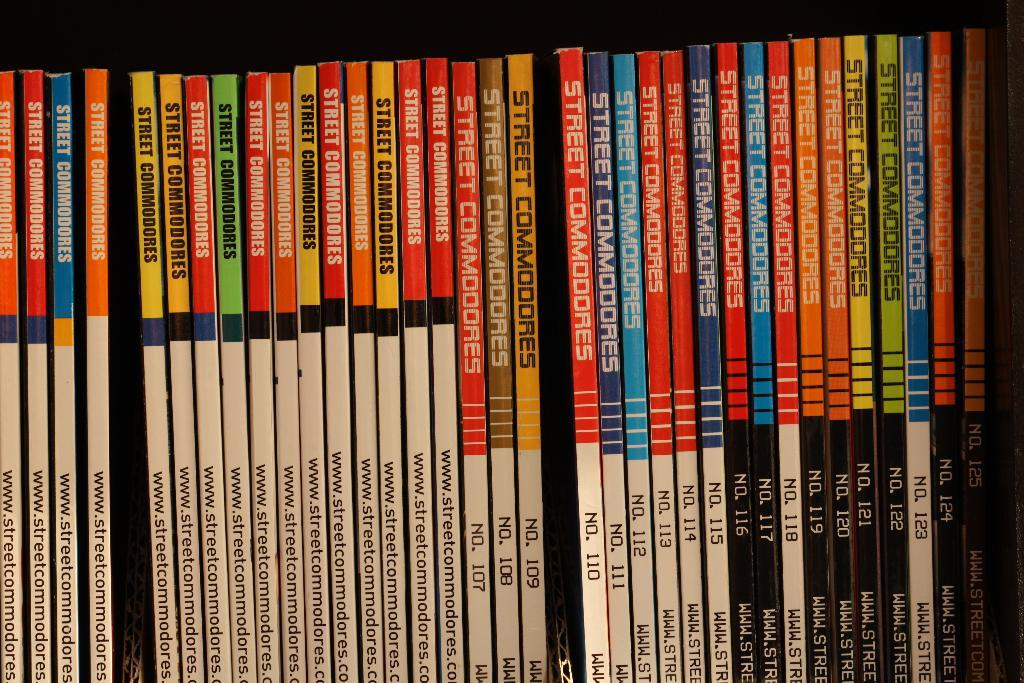<image>
Render a clear and concise summary of the photo. a lot of street commodores are lines up side by side on a shelf 